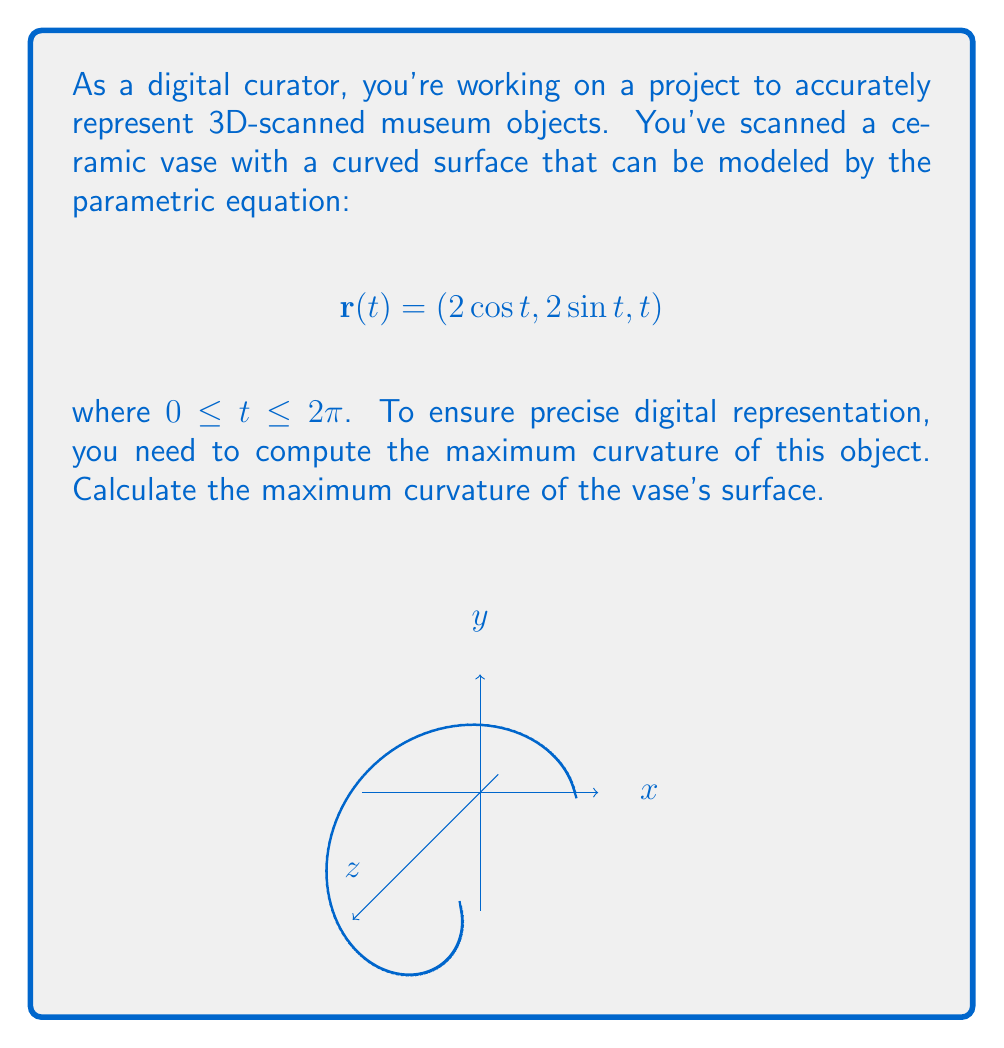Provide a solution to this math problem. To find the maximum curvature, we'll follow these steps:

1) First, we need to calculate $\mathbf{r}'(t)$ and $\mathbf{r}''(t)$:

   $$\mathbf{r}'(t) = (-2\sin t, 2\cos t, 1)$$
   $$\mathbf{r}''(t) = (-2\cos t, -2\sin t, 0)$$

2) The curvature $\kappa$ is given by:

   $$\kappa = \frac{|\mathbf{r}'(t) \times \mathbf{r}''(t)|}{|\mathbf{r}'(t)|^3}$$

3) Let's calculate the cross product $\mathbf{r}'(t) \times \mathbf{r}''(t)$:

   $$\mathbf{r}'(t) \times \mathbf{r}''(t) = \begin{vmatrix} 
   \mathbf{i} & \mathbf{j} & \mathbf{k} \\
   -2\sin t & 2\cos t & 1 \\
   -2\cos t & -2\sin t & 0
   \end{vmatrix}$$

   $$= (-2\cos t, -2\sin t, -4)$$

4) Now, let's calculate the magnitudes:

   $$|\mathbf{r}'(t) \times \mathbf{r}''(t)| = \sqrt{4\cos^2 t + 4\sin^2 t + 16} = \sqrt{4 + 16} = \sqrt{20} = 2\sqrt{5}$$

   $$|\mathbf{r}'(t)| = \sqrt{4\sin^2 t + 4\cos^2 t + 1} = \sqrt{5}$$

5) Substituting into the curvature formula:

   $$\kappa = \frac{2\sqrt{5}}{(\sqrt{5})^3} = \frac{2\sqrt{5}}{5\sqrt{5}} = \frac{2}{5}$$

6) Since this curvature is constant (doesn't depend on $t$), it's also the maximum curvature.
Answer: $\frac{2}{5}$ 